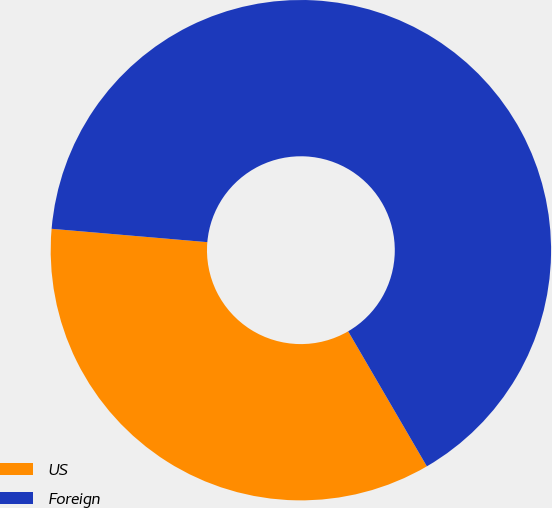Convert chart to OTSL. <chart><loc_0><loc_0><loc_500><loc_500><pie_chart><fcel>US<fcel>Foreign<nl><fcel>34.76%<fcel>65.24%<nl></chart> 